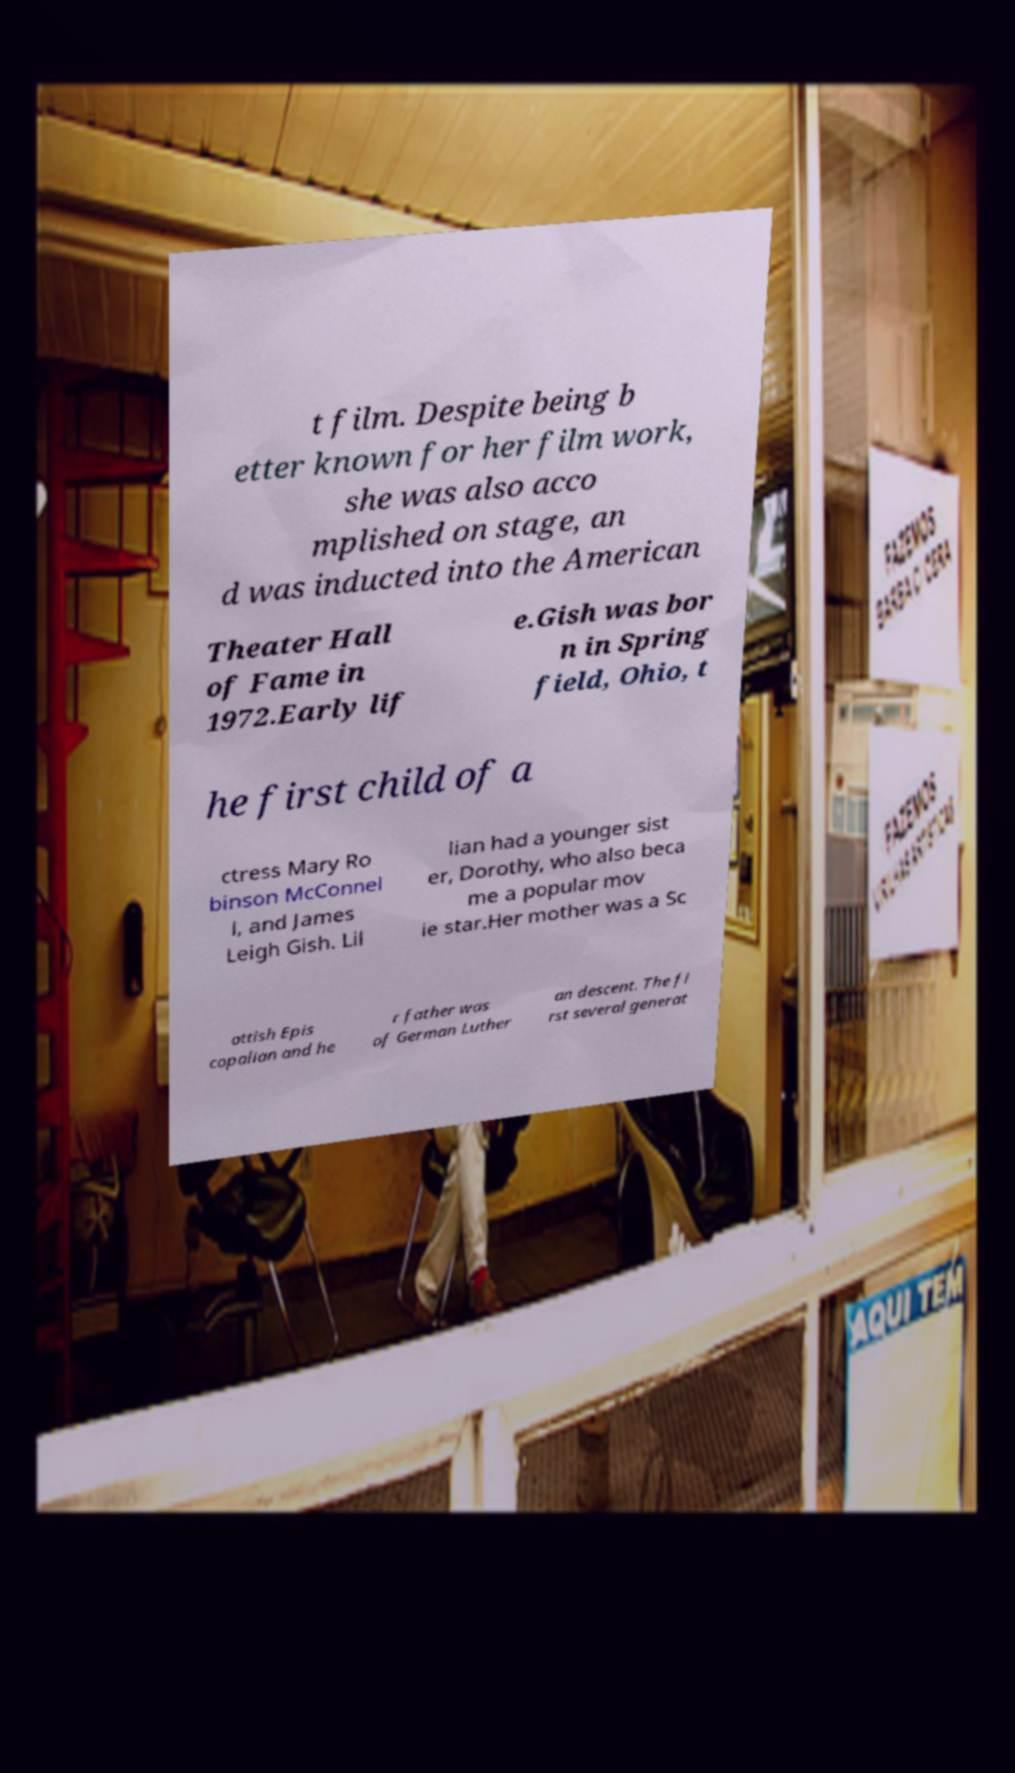Please read and relay the text visible in this image. What does it say? t film. Despite being b etter known for her film work, she was also acco mplished on stage, an d was inducted into the American Theater Hall of Fame in 1972.Early lif e.Gish was bor n in Spring field, Ohio, t he first child of a ctress Mary Ro binson McConnel l, and James Leigh Gish. Lil lian had a younger sist er, Dorothy, who also beca me a popular mov ie star.Her mother was a Sc ottish Epis copalian and he r father was of German Luther an descent. The fi rst several generat 